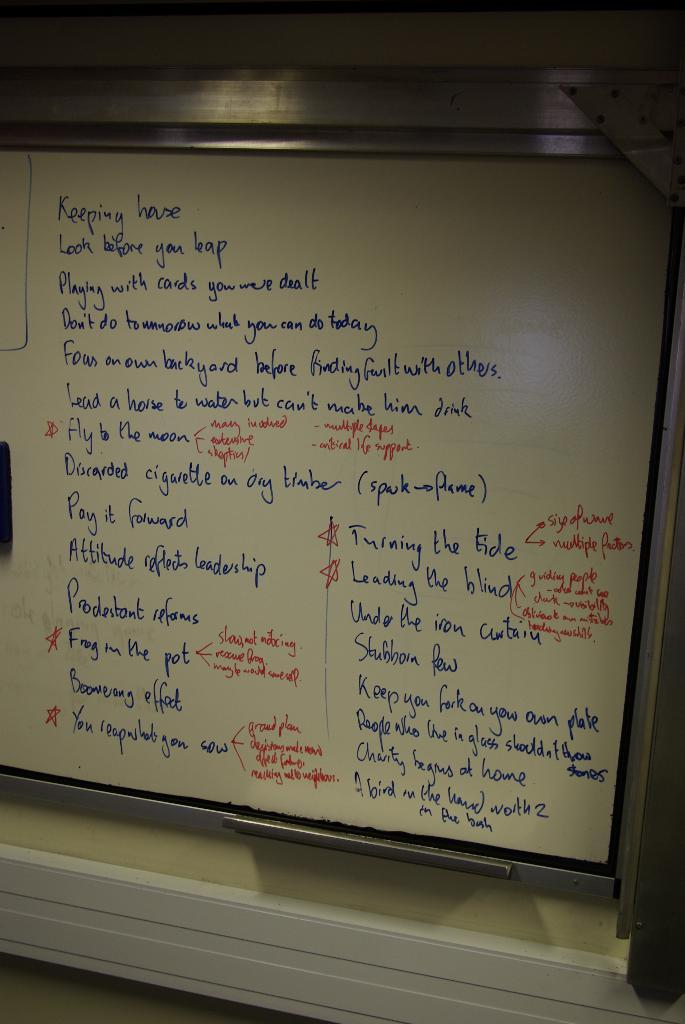<image>
Create a compact narrative representing the image presented. A whiteboard has a list of rules including "Look before you leap" and "Pay it forward" written on it. 